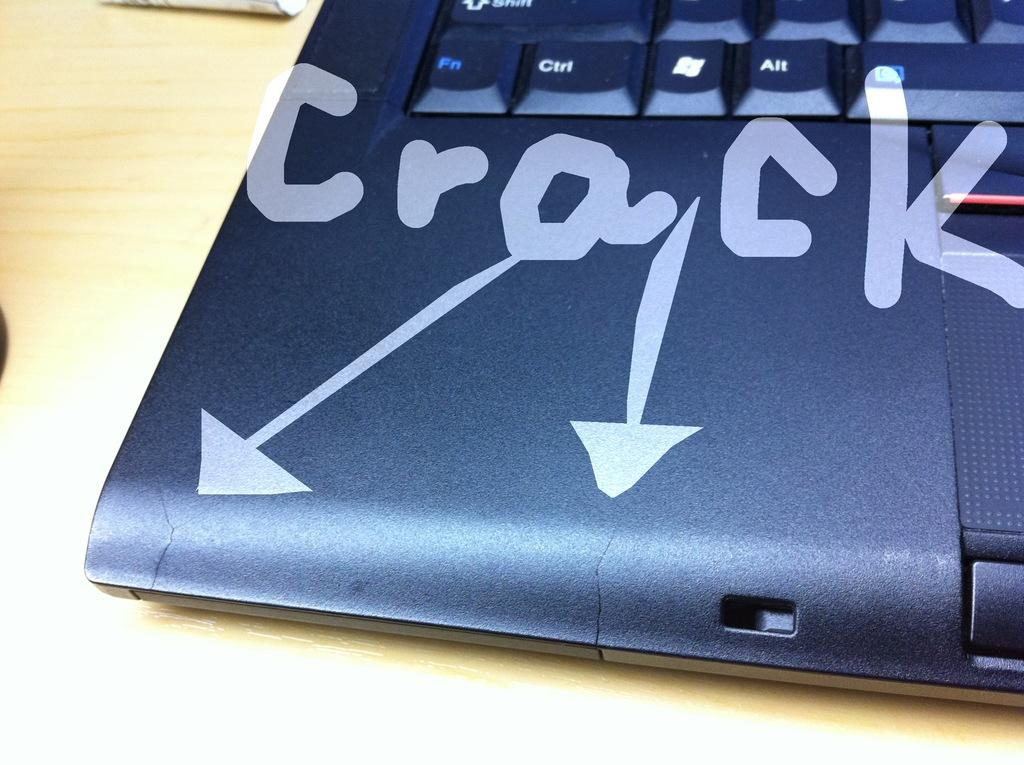Provide a one-sentence caption for the provided image. Black laptop with focus on the bottom left, arrows pointing to cracks. 